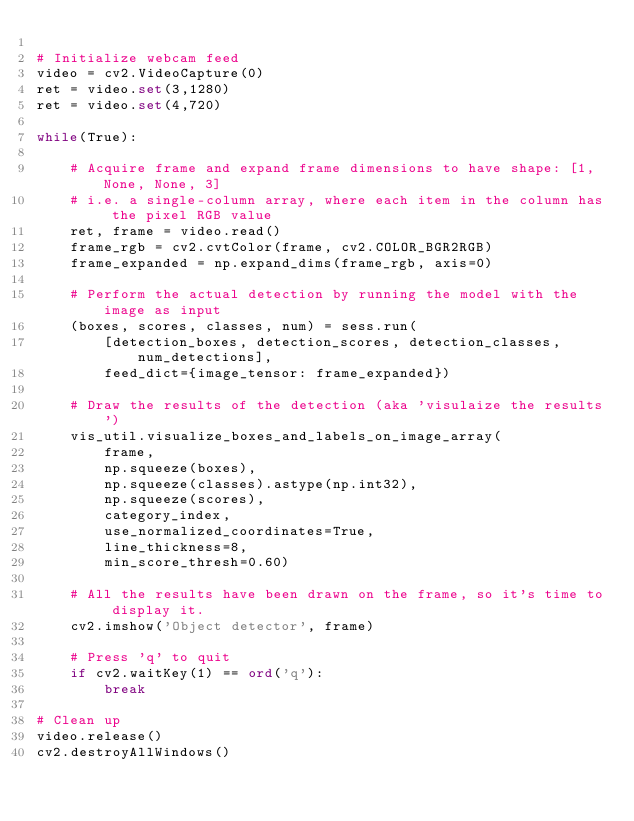<code> <loc_0><loc_0><loc_500><loc_500><_Python_>
# Initialize webcam feed
video = cv2.VideoCapture(0)
ret = video.set(3,1280)
ret = video.set(4,720)

while(True):

    # Acquire frame and expand frame dimensions to have shape: [1, None, None, 3]
    # i.e. a single-column array, where each item in the column has the pixel RGB value
    ret, frame = video.read()
    frame_rgb = cv2.cvtColor(frame, cv2.COLOR_BGR2RGB)
    frame_expanded = np.expand_dims(frame_rgb, axis=0)

    # Perform the actual detection by running the model with the image as input
    (boxes, scores, classes, num) = sess.run(
        [detection_boxes, detection_scores, detection_classes, num_detections],
        feed_dict={image_tensor: frame_expanded})

    # Draw the results of the detection (aka 'visulaize the results')
    vis_util.visualize_boxes_and_labels_on_image_array(
        frame,
        np.squeeze(boxes),
        np.squeeze(classes).astype(np.int32),
        np.squeeze(scores),
        category_index,
        use_normalized_coordinates=True,
        line_thickness=8,
        min_score_thresh=0.60)

    # All the results have been drawn on the frame, so it's time to display it.
    cv2.imshow('Object detector', frame)

    # Press 'q' to quit
    if cv2.waitKey(1) == ord('q'):
        break

# Clean up
video.release()
cv2.destroyAllWindows()

</code> 